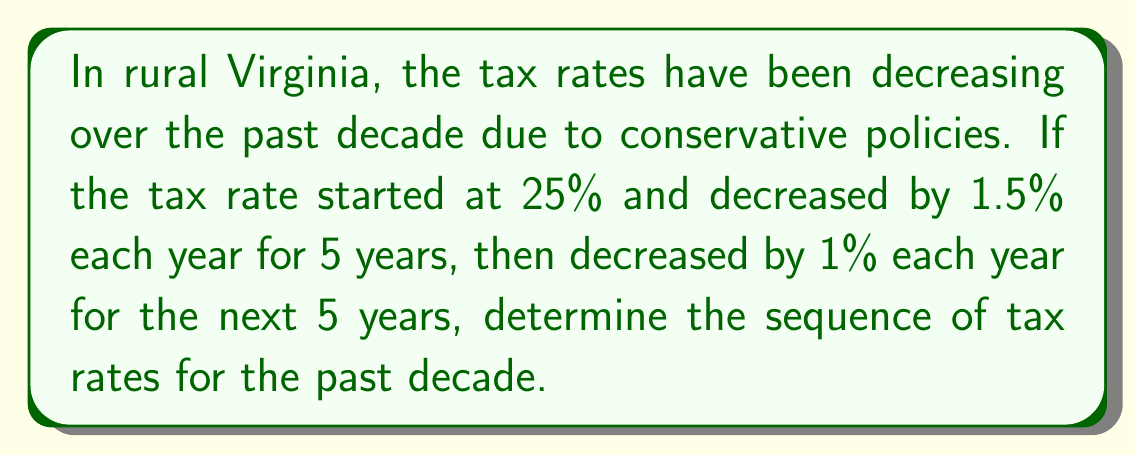Show me your answer to this math problem. Let's approach this step-by-step:

1) We start with a 25% tax rate.

2) For the first 5 years, the rate decreases by 1.5% each year:
   Year 1: $25\% - 1.5\% = 23.5\%$
   Year 2: $23.5\% - 1.5\% = 22\%$
   Year 3: $22\% - 1.5\% = 20.5\%$
   Year 4: $20.5\% - 1.5\% = 19\%$
   Year 5: $19\% - 1.5\% = 17.5\%$

3) For the next 5 years, the rate decreases by 1% each year:
   Year 6: $17.5\% - 1\% = 16.5\%$
   Year 7: $16.5\% - 1\% = 15.5\%$
   Year 8: $15.5\% - 1\% = 14.5\%$
   Year 9: $14.5\% - 1\% = 13.5\%$
   Year 10: $13.5\% - 1\% = 12.5\%$

4) Therefore, the sequence of tax rates over the past decade is:
   $$25\%, 23.5\%, 22\%, 20.5\%, 19\%, 17.5\%, 16.5\%, 15.5\%, 14.5\%, 13.5\%, 12.5\%$$
Answer: $25\%, 23.5\%, 22\%, 20.5\%, 19\%, 17.5\%, 16.5\%, 15.5\%, 14.5\%, 13.5\%, 12.5\%$ 